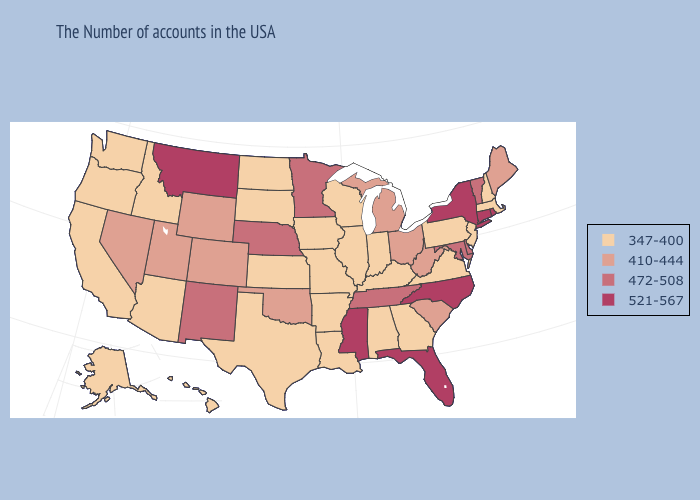Does the map have missing data?
Keep it brief. No. How many symbols are there in the legend?
Quick response, please. 4. What is the lowest value in states that border Arkansas?
Short answer required. 347-400. Does Mississippi have the lowest value in the South?
Keep it brief. No. Does Michigan have a higher value than Nevada?
Keep it brief. No. What is the lowest value in the South?
Keep it brief. 347-400. Name the states that have a value in the range 410-444?
Concise answer only. Maine, South Carolina, West Virginia, Ohio, Michigan, Oklahoma, Wyoming, Colorado, Utah, Nevada. What is the value of Hawaii?
Concise answer only. 347-400. What is the highest value in the USA?
Write a very short answer. 521-567. What is the value of Ohio?
Write a very short answer. 410-444. Among the states that border Missouri , which have the highest value?
Short answer required. Tennessee, Nebraska. What is the lowest value in the MidWest?
Quick response, please. 347-400. Name the states that have a value in the range 410-444?
Keep it brief. Maine, South Carolina, West Virginia, Ohio, Michigan, Oklahoma, Wyoming, Colorado, Utah, Nevada. Name the states that have a value in the range 410-444?
Concise answer only. Maine, South Carolina, West Virginia, Ohio, Michigan, Oklahoma, Wyoming, Colorado, Utah, Nevada. What is the highest value in the USA?
Quick response, please. 521-567. 